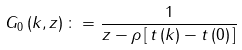Convert formula to latex. <formula><loc_0><loc_0><loc_500><loc_500>G _ { 0 } \left ( k , z \right ) \colon = \frac { 1 } { z - \rho \left [ \, t \left ( k \right ) - t \left ( 0 \right ) \, \right ] }</formula> 